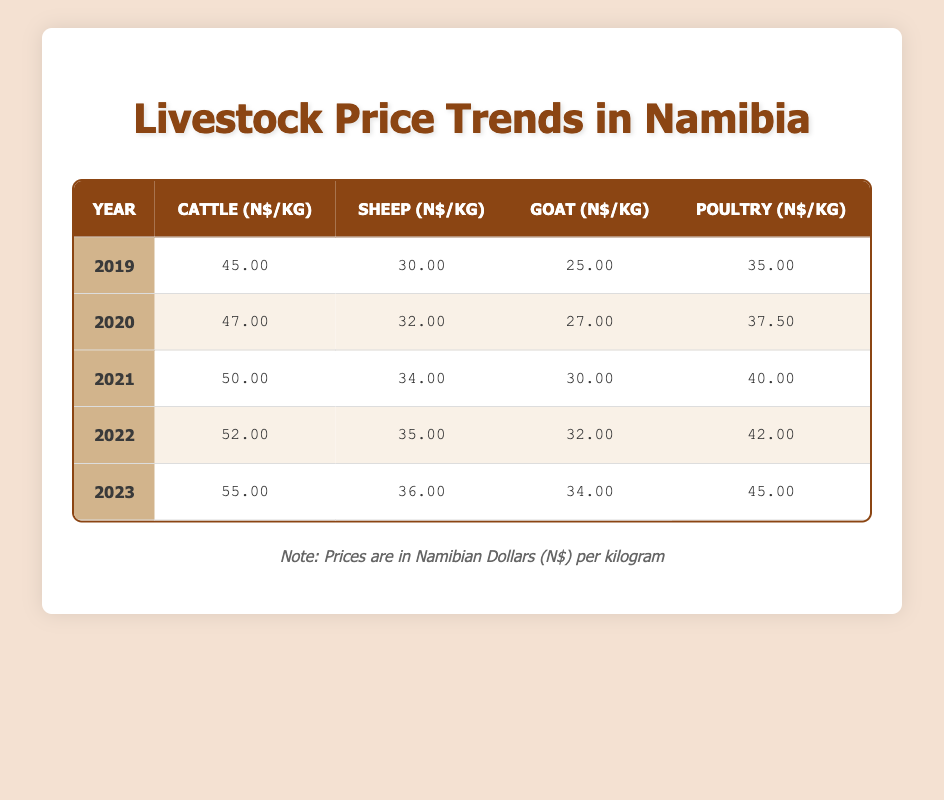What was the average price of cattle per kg over the last five years? To calculate the average price of cattle per kg, we sum the prices from each year: (45 + 47 + 50 + 52 + 55) = 249. There are five years, so we divide the total by 5: 249 / 5 = 49.8.
Answer: 49.8 In which year did goat prices see the highest increase compared to the previous year? To find this, we look at the prices each year: 25 (2019), 27 (2020), 30 (2021), 32 (2022), and 34 (2023). The increases are 2 (2020), 3 (2021), 2 (2022), and 2 (2023). The highest increase is from 2020 to 2021 (3).
Answer: 2021 Was the price per kg of sheep higher in 2023 than in 2021? The price in 2023 is 36, and in 2021 it's 34. Since 36 is greater than 34, the price in 2023 was indeed higher than in 2021.
Answer: Yes What was the overall trend in poultry prices from 2019 to 2023? The poultry prices over the years are: 35 (2019), 37.5 (2020), 40 (2021), 42 (2022), 45 (2023). We can see that the prices consistently increased each year (by 2.5, 2.5, 2, and 3), indicating an upward trend overall.
Answer: Upward trend Which livestock had the highest price per kg in 2022? In 2022, the prices were: cattle 52, sheep 35, goat 32, and poultry 42. The highest price among these is 52 for cattle.
Answer: Cattle 